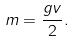<formula> <loc_0><loc_0><loc_500><loc_500>m = \frac { g v } { 2 } .</formula> 